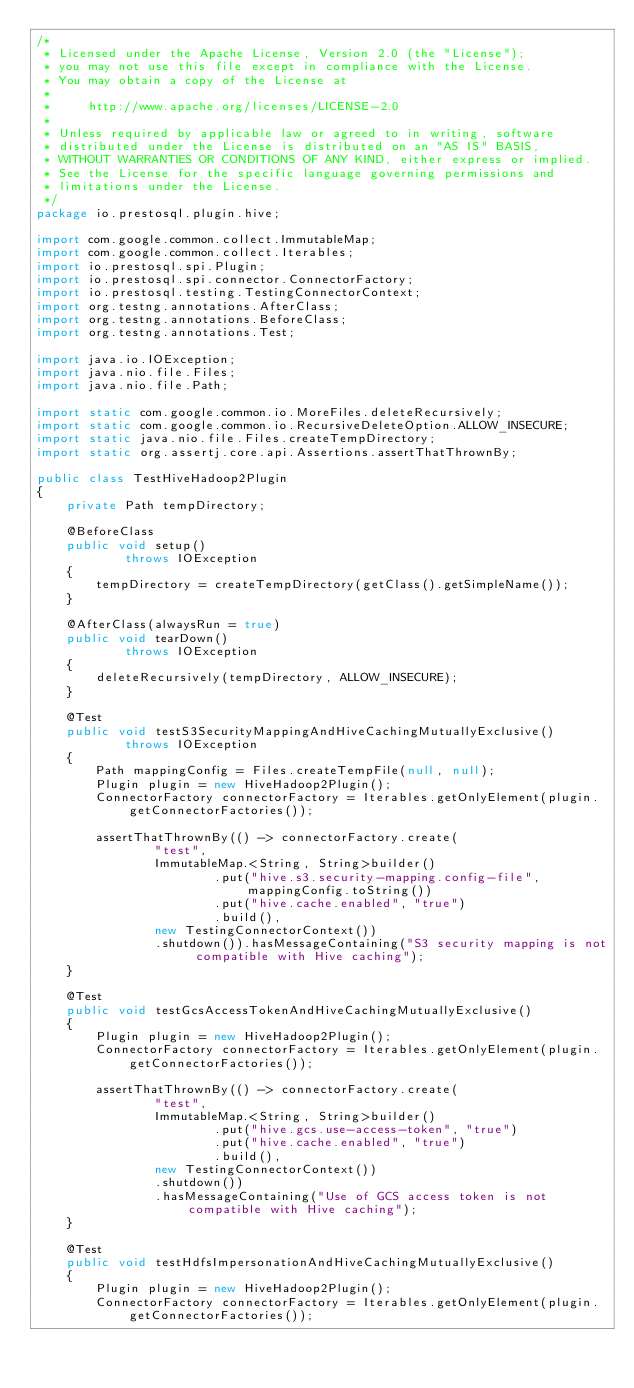<code> <loc_0><loc_0><loc_500><loc_500><_Java_>/*
 * Licensed under the Apache License, Version 2.0 (the "License");
 * you may not use this file except in compliance with the License.
 * You may obtain a copy of the License at
 *
 *     http://www.apache.org/licenses/LICENSE-2.0
 *
 * Unless required by applicable law or agreed to in writing, software
 * distributed under the License is distributed on an "AS IS" BASIS,
 * WITHOUT WARRANTIES OR CONDITIONS OF ANY KIND, either express or implied.
 * See the License for the specific language governing permissions and
 * limitations under the License.
 */
package io.prestosql.plugin.hive;

import com.google.common.collect.ImmutableMap;
import com.google.common.collect.Iterables;
import io.prestosql.spi.Plugin;
import io.prestosql.spi.connector.ConnectorFactory;
import io.prestosql.testing.TestingConnectorContext;
import org.testng.annotations.AfterClass;
import org.testng.annotations.BeforeClass;
import org.testng.annotations.Test;

import java.io.IOException;
import java.nio.file.Files;
import java.nio.file.Path;

import static com.google.common.io.MoreFiles.deleteRecursively;
import static com.google.common.io.RecursiveDeleteOption.ALLOW_INSECURE;
import static java.nio.file.Files.createTempDirectory;
import static org.assertj.core.api.Assertions.assertThatThrownBy;

public class TestHiveHadoop2Plugin
{
    private Path tempDirectory;

    @BeforeClass
    public void setup()
            throws IOException
    {
        tempDirectory = createTempDirectory(getClass().getSimpleName());
    }

    @AfterClass(alwaysRun = true)
    public void tearDown()
            throws IOException
    {
        deleteRecursively(tempDirectory, ALLOW_INSECURE);
    }

    @Test
    public void testS3SecurityMappingAndHiveCachingMutuallyExclusive()
            throws IOException
    {
        Path mappingConfig = Files.createTempFile(null, null);
        Plugin plugin = new HiveHadoop2Plugin();
        ConnectorFactory connectorFactory = Iterables.getOnlyElement(plugin.getConnectorFactories());

        assertThatThrownBy(() -> connectorFactory.create(
                "test",
                ImmutableMap.<String, String>builder()
                        .put("hive.s3.security-mapping.config-file", mappingConfig.toString())
                        .put("hive.cache.enabled", "true")
                        .build(),
                new TestingConnectorContext())
                .shutdown()).hasMessageContaining("S3 security mapping is not compatible with Hive caching");
    }

    @Test
    public void testGcsAccessTokenAndHiveCachingMutuallyExclusive()
    {
        Plugin plugin = new HiveHadoop2Plugin();
        ConnectorFactory connectorFactory = Iterables.getOnlyElement(plugin.getConnectorFactories());

        assertThatThrownBy(() -> connectorFactory.create(
                "test",
                ImmutableMap.<String, String>builder()
                        .put("hive.gcs.use-access-token", "true")
                        .put("hive.cache.enabled", "true")
                        .build(),
                new TestingConnectorContext())
                .shutdown())
                .hasMessageContaining("Use of GCS access token is not compatible with Hive caching");
    }

    @Test
    public void testHdfsImpersonationAndHiveCachingMutuallyExclusive()
    {
        Plugin plugin = new HiveHadoop2Plugin();
        ConnectorFactory connectorFactory = Iterables.getOnlyElement(plugin.getConnectorFactories());
</code> 